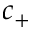Convert formula to latex. <formula><loc_0><loc_0><loc_500><loc_500>c _ { + }</formula> 